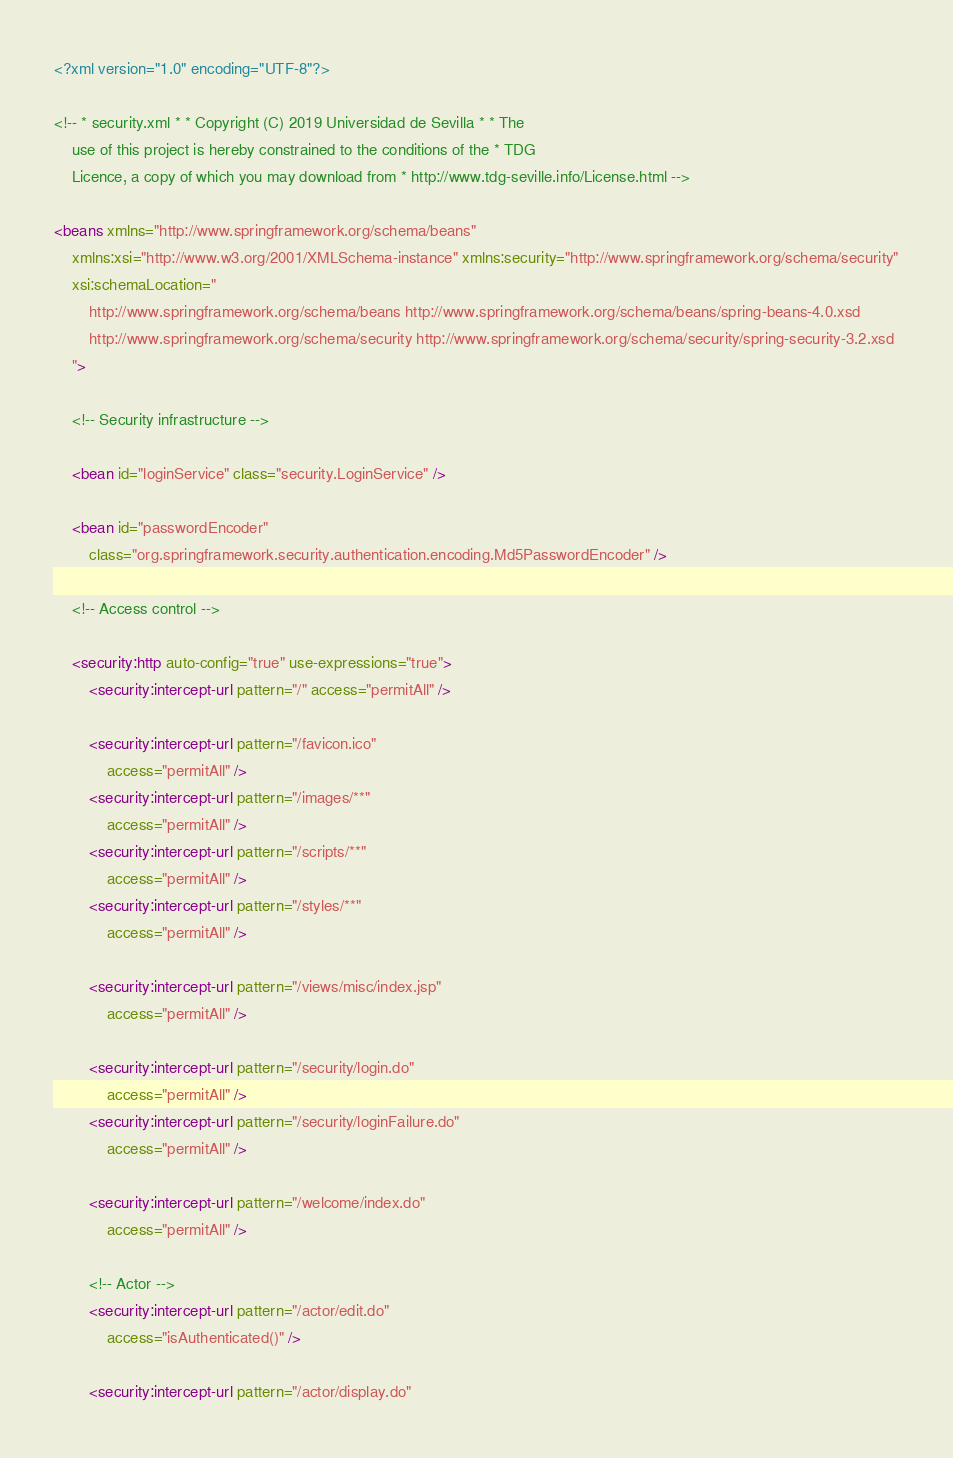<code> <loc_0><loc_0><loc_500><loc_500><_XML_><?xml version="1.0" encoding="UTF-8"?>

<!-- * security.xml * * Copyright (C) 2019 Universidad de Sevilla * * The 
	use of this project is hereby constrained to the conditions of the * TDG 
	Licence, a copy of which you may download from * http://www.tdg-seville.info/License.html -->

<beans xmlns="http://www.springframework.org/schema/beans"
	xmlns:xsi="http://www.w3.org/2001/XMLSchema-instance" xmlns:security="http://www.springframework.org/schema/security"
	xsi:schemaLocation="
		http://www.springframework.org/schema/beans http://www.springframework.org/schema/beans/spring-beans-4.0.xsd		
        http://www.springframework.org/schema/security http://www.springframework.org/schema/security/spring-security-3.2.xsd
    ">

	<!-- Security infrastructure -->

	<bean id="loginService" class="security.LoginService" />

	<bean id="passwordEncoder"
		class="org.springframework.security.authentication.encoding.Md5PasswordEncoder" />

	<!-- Access control -->

	<security:http auto-config="true" use-expressions="true">
		<security:intercept-url pattern="/" access="permitAll" />

		<security:intercept-url pattern="/favicon.ico"
			access="permitAll" />
		<security:intercept-url pattern="/images/**"
			access="permitAll" />
		<security:intercept-url pattern="/scripts/**"
			access="permitAll" />
		<security:intercept-url pattern="/styles/**"
			access="permitAll" />

		<security:intercept-url pattern="/views/misc/index.jsp"
			access="permitAll" />

		<security:intercept-url pattern="/security/login.do"
			access="permitAll" />
		<security:intercept-url pattern="/security/loginFailure.do"
			access="permitAll" />

		<security:intercept-url pattern="/welcome/index.do"
			access="permitAll" />

		<!-- Actor -->
		<security:intercept-url pattern="/actor/edit.do"
			access="isAuthenticated()" />

		<security:intercept-url pattern="/actor/display.do"</code> 